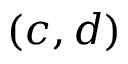Convert formula to latex. <formula><loc_0><loc_0><loc_500><loc_500>( c , d )</formula> 